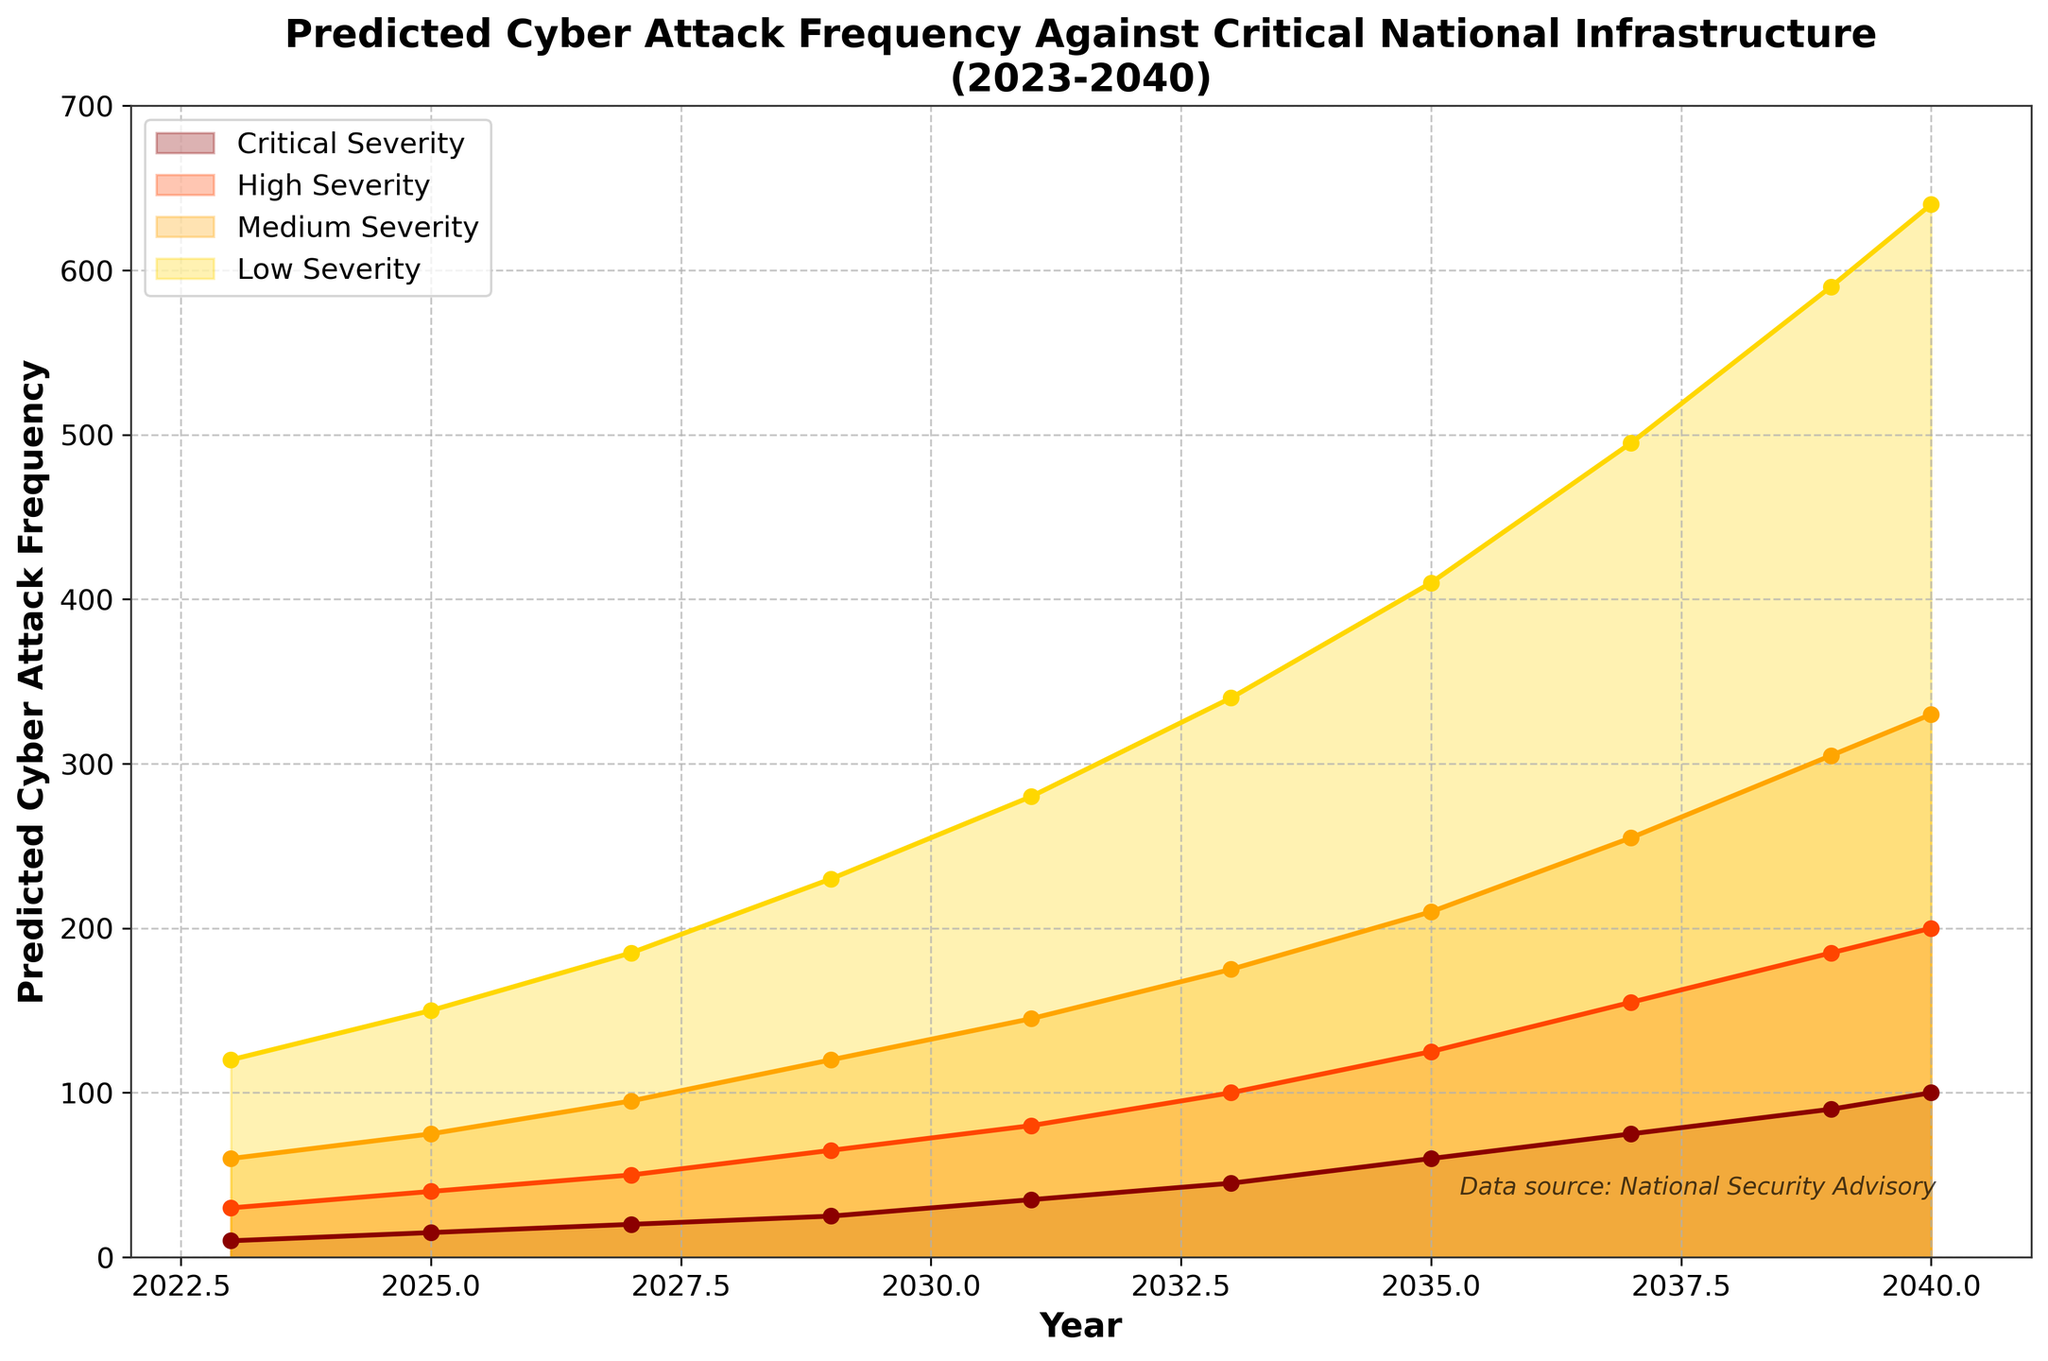What's the predicted frequency of low-severity cyber attacks in 2023? Look at the y-axis for the predicted frequency and find the corresponding value on the graph for the year 2023 under the 'Low Severity' label.
Answer: 120 What's the total predicted frequency of all types of cyber attacks in 2027? Sum the predicted frequencies for Low (185), Medium (95), High (50), and Critical (20) severities in the year 2027. 185 + 95 + 50 + 20 = 350
Answer: 350 In which year is the predicted frequency of medium-severity cyber attacks expected to reach 305? Inspect the line for 'Medium Severity' and find the point where it reaches 305 on the y-axis. The corresponding year on the x-axis is 2039.
Answer: 2039 Which severity level of cyber attacks has the greatest increase in predicted frequency from 2023 to 2040? Compare the predicted frequencies in 2023 and 2040 for each severity level. The difference for Low is (640 - 120 = 520), Medium (330 - 60 = 270), High (200 - 30 = 170), Critical (100 - 10 = 90). Low Severity has the greatest increase.
Answer: Low Severity What is the average predicted frequency of high-severity attacks for the years 2023, 2029, and 2035? Sum the predicted frequencies for High-Severity attacks for 2023 (30), 2029 (65), and 2035 (125) and divide by the number of years (3). (30 + 65 + 125) / 3 = 220 / 3 ≈ 73.33
Answer: 73.33 How does the predicted frequency of critical-severity attacks in 2033 compare to that in 2027? Look at the y-axis values for 2033 (45) and 2027 (20) under the 'Critical Severity' label. Then find the difference: 45 - 20 = 25. The frequency in 2033 is higher by 25.
Answer: Higher by 25 What is the ratio of predicted low-severity attacks to critical-severity attacks in the year 2040? Divide the predicted frequency of low-severity attacks (640) by the predicted frequency of critical-severity attacks (100) for the year 2040. 640 / 100 = 6.4
Answer: 6.4 If the frequencies for medium-severity attacks in 2025 and 2035 are combined, what would their total be? Sum the predicted frequencies for Medium-Severity attacks in 2025 (75) and 2035 (210). 75 + 210 = 285
Answer: 285 